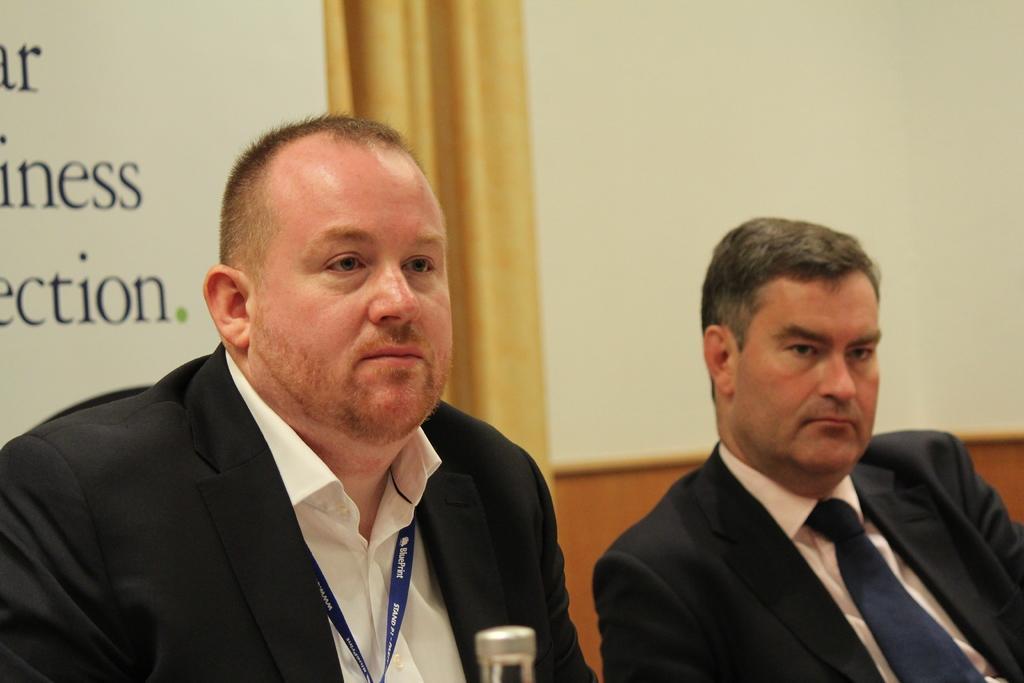Can you describe this image briefly? In this image we can see two people sitting. They are wearing suits. In the background there are boards and a curtain. 